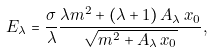<formula> <loc_0><loc_0><loc_500><loc_500>E _ { \lambda } = \frac { \sigma } { \lambda } \frac { \lambda m ^ { 2 } + ( \lambda + 1 ) \, A _ { \lambda } \, x _ { 0 } } { \sqrt { m ^ { 2 } + A _ { \lambda } \, x _ { 0 } } } ,</formula> 